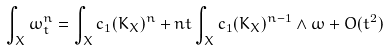Convert formula to latex. <formula><loc_0><loc_0><loc_500><loc_500>\int _ { X } \omega _ { t } ^ { n } = \int _ { X } c _ { 1 } ( K _ { X } ) ^ { n } + n t \int _ { X } c _ { 1 } ( K _ { X } ) ^ { n - 1 } \wedge \omega + O ( t ^ { 2 } )</formula> 